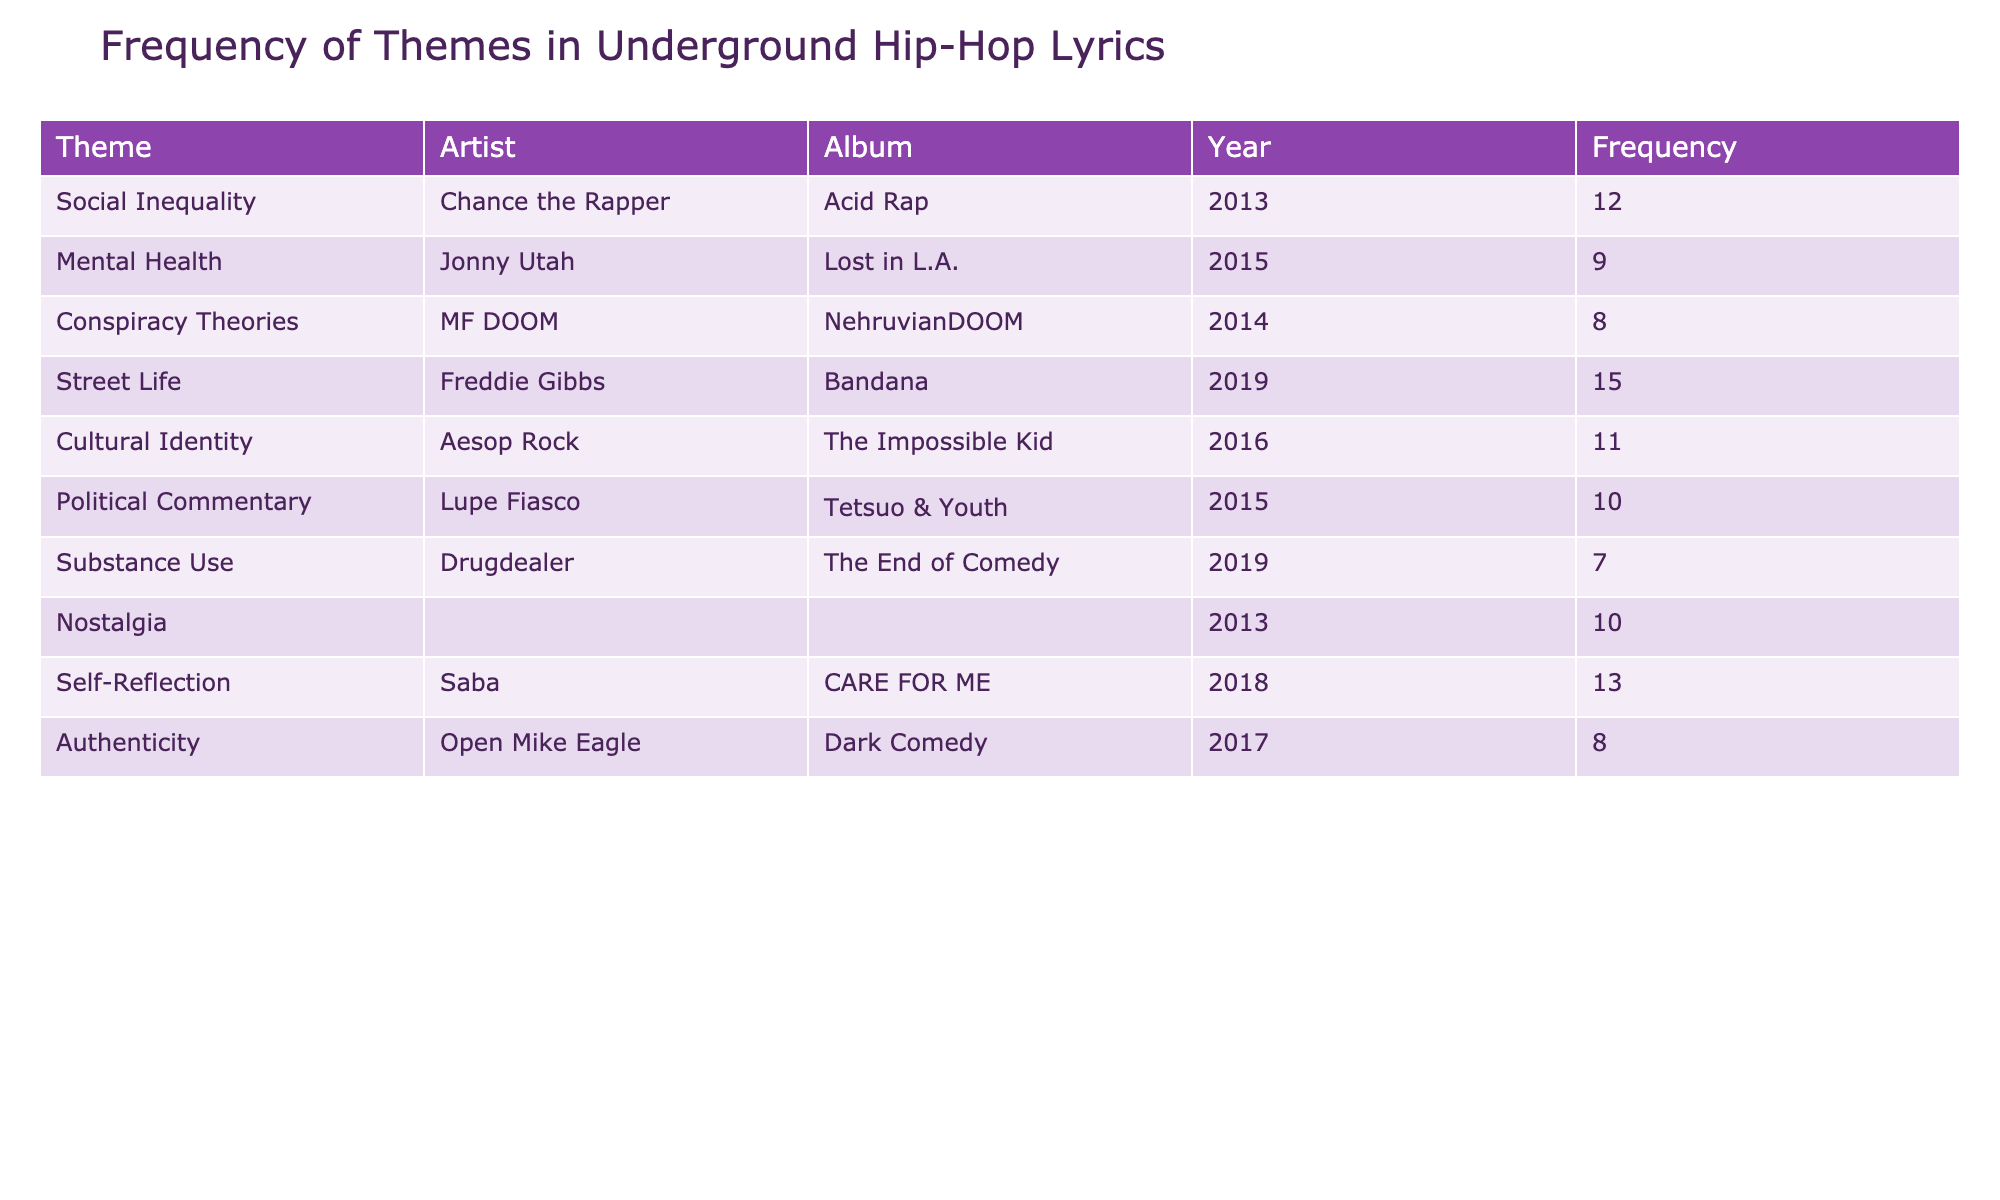What is the theme with the highest frequency in underground hip-hop lyrics? The table shows the frequency of each theme in underground hip-hop lyrics. By checking the frequency values, "Street Life" is listed with a frequency of 15, which is the highest among all the themes.
Answer: Street Life Which artist discussed Mental Health in their lyrics, and what is the frequency of this theme? The table lists "Mental Health" as a theme and associates it with the artist Jonny Utah, who has a frequency of 9 for this theme.
Answer: Jonny Utah, Frequency: 9 How many themes are discussed by Freddie Gibbs in total? Freddie Gibbs is mentioned with one theme, "Street Life," which has a frequency of 15. Since he only appears once in the table, the total number of themes associated with him is 1.
Answer: 1 Is there a theme related to Nostalgia, and if so, what is its frequency? The table indicates that "Nostalgia" is indeed a theme, and it is associated with the artist Joey Bada$$ who has a frequency of 10 for this theme.
Answer: Yes, Frequency: 10 What is the average frequency of themes related to social issues (Social Inequality and Political Commentary)? We find the frequencies for "Social Inequality" (12) and "Political Commentary" (10). The average is calculated by summing the two frequencies (12 + 10 = 22) and dividing by the number of themes (22 / 2 = 11).
Answer: 11 Which artist has the lowest frequency related to Substance Use, and what is the value? The table shows that Drugdealer is the only artist associated with "Substance Use" theme, which has a frequency of 7. Hence, Drugdealer has the lowest frequency for this theme.
Answer: Drugdealer, Frequency: 7 Are there any artists who discuss both street life and mental health? By examining the table, no artist is listed under both themes "Street Life" (Freddie Gibbs) and "Mental Health" (Jonny Utah). Therefore, the answer is no.
Answer: No What is the total frequency of themes related to self-reflection and authenticity combined? The themes "Self-Reflection" has a frequency of 13 and "Authenticity" has a frequency of 8. Summing these values gives 13 + 8 = 21.
Answer: 21 What year did Lupe Fiasco release an album with Political Commentary, and how frequent is this theme? The table shows that Lupe Fiasco is associated with "Political Commentary" in the album "Tetsuo & Youth," released in 2015, and the theme has a frequency of 10.
Answer: Year: 2015, Frequency: 10 